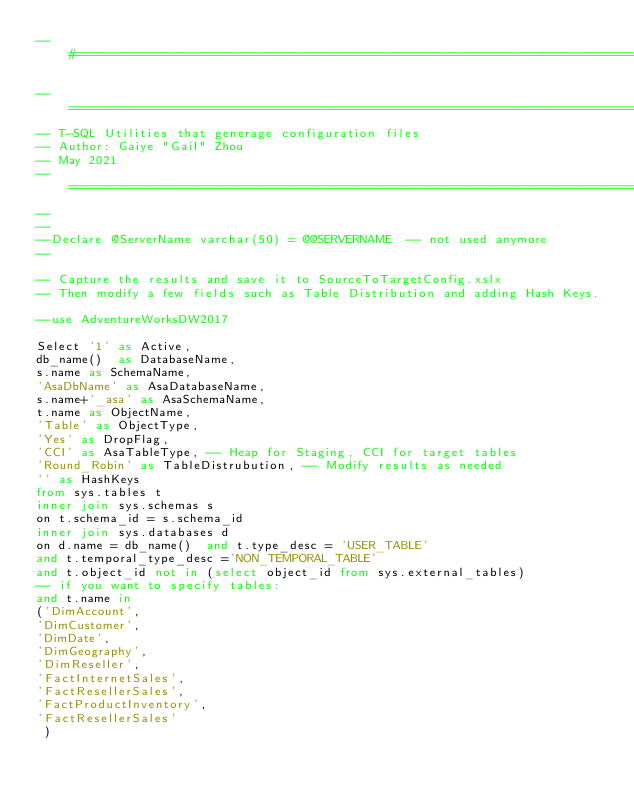<code> <loc_0><loc_0><loc_500><loc_500><_SQL_>--#======================================================================================================================#

--======================================================================================================================#
-- T-SQL Utilities that generage configuration files
-- Author: Gaiye "Gail" Zhou 
-- May 2021 
--======================================================================================================================#
--
--
--Declare @ServerName varchar(50) = @@SERVERNAME  -- not used anymore 
--

-- Capture the results and save it to SourceToTargetConfig.xslx 
-- Then modify a few fields such as Table Distribution and adding Hash Keys. 

--use AdventureWorksDW2017

Select '1' as Active, 
db_name()  as DatabaseName, 
s.name as SchemaName, 
'AsaDbName' as AsaDatabaseName,
s.name+'_asa' as AsaSchemaName,
t.name as ObjectName, 
'Table' as ObjectType,
'Yes' as DropFlag,
'CCI' as AsaTableType, -- Heap for Staging, CCI for target tables
'Round_Robin' as TableDistrubution, -- Modify results as needed 
'' as HashKeys
from sys.tables t 
inner join sys.schemas s 
on t.schema_id = s.schema_id 
inner join sys.databases d
on d.name = db_name()  and t.type_desc = 'USER_TABLE' 
and t.temporal_type_desc ='NON_TEMPORAL_TABLE' 
and t.object_id not in (select object_id from sys.external_tables)
-- if you want to specify tables:
and t.name in 
('DimAccount',
'DimCustomer', 
'DimDate', 
'DimGeography',
'DimReseller', 
'FactInternetSales',
'FactResellerSales',
'FactProductInventory',
'FactResellerSales'
 ) 
</code> 